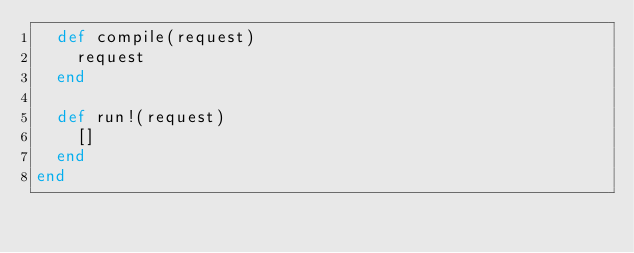Convert code to text. <code><loc_0><loc_0><loc_500><loc_500><_Ruby_>  def compile(request)
    request
  end

  def run!(request)
    []
  end
end
</code> 